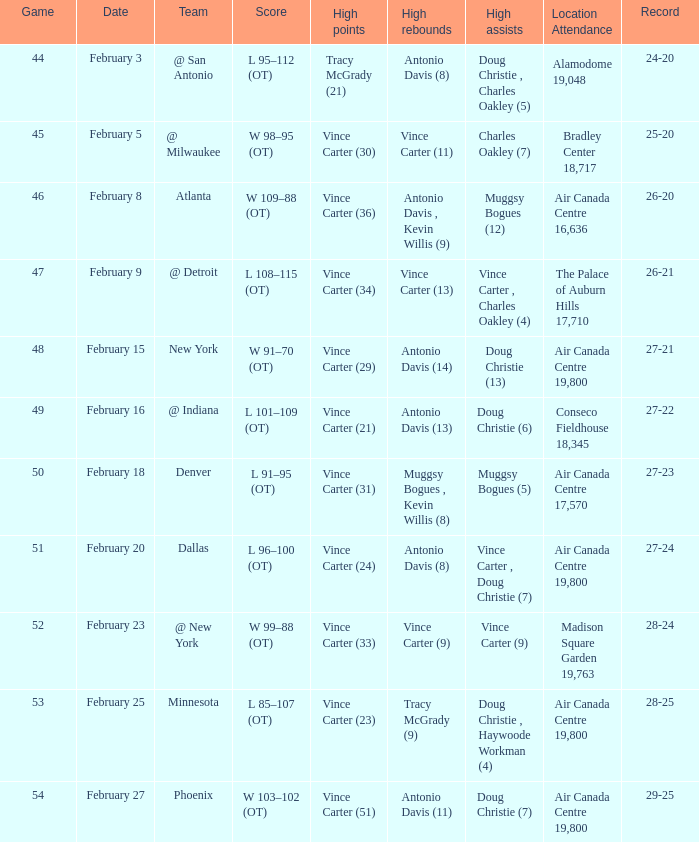How many contests were conducted when the record was 26-21? 1.0. 